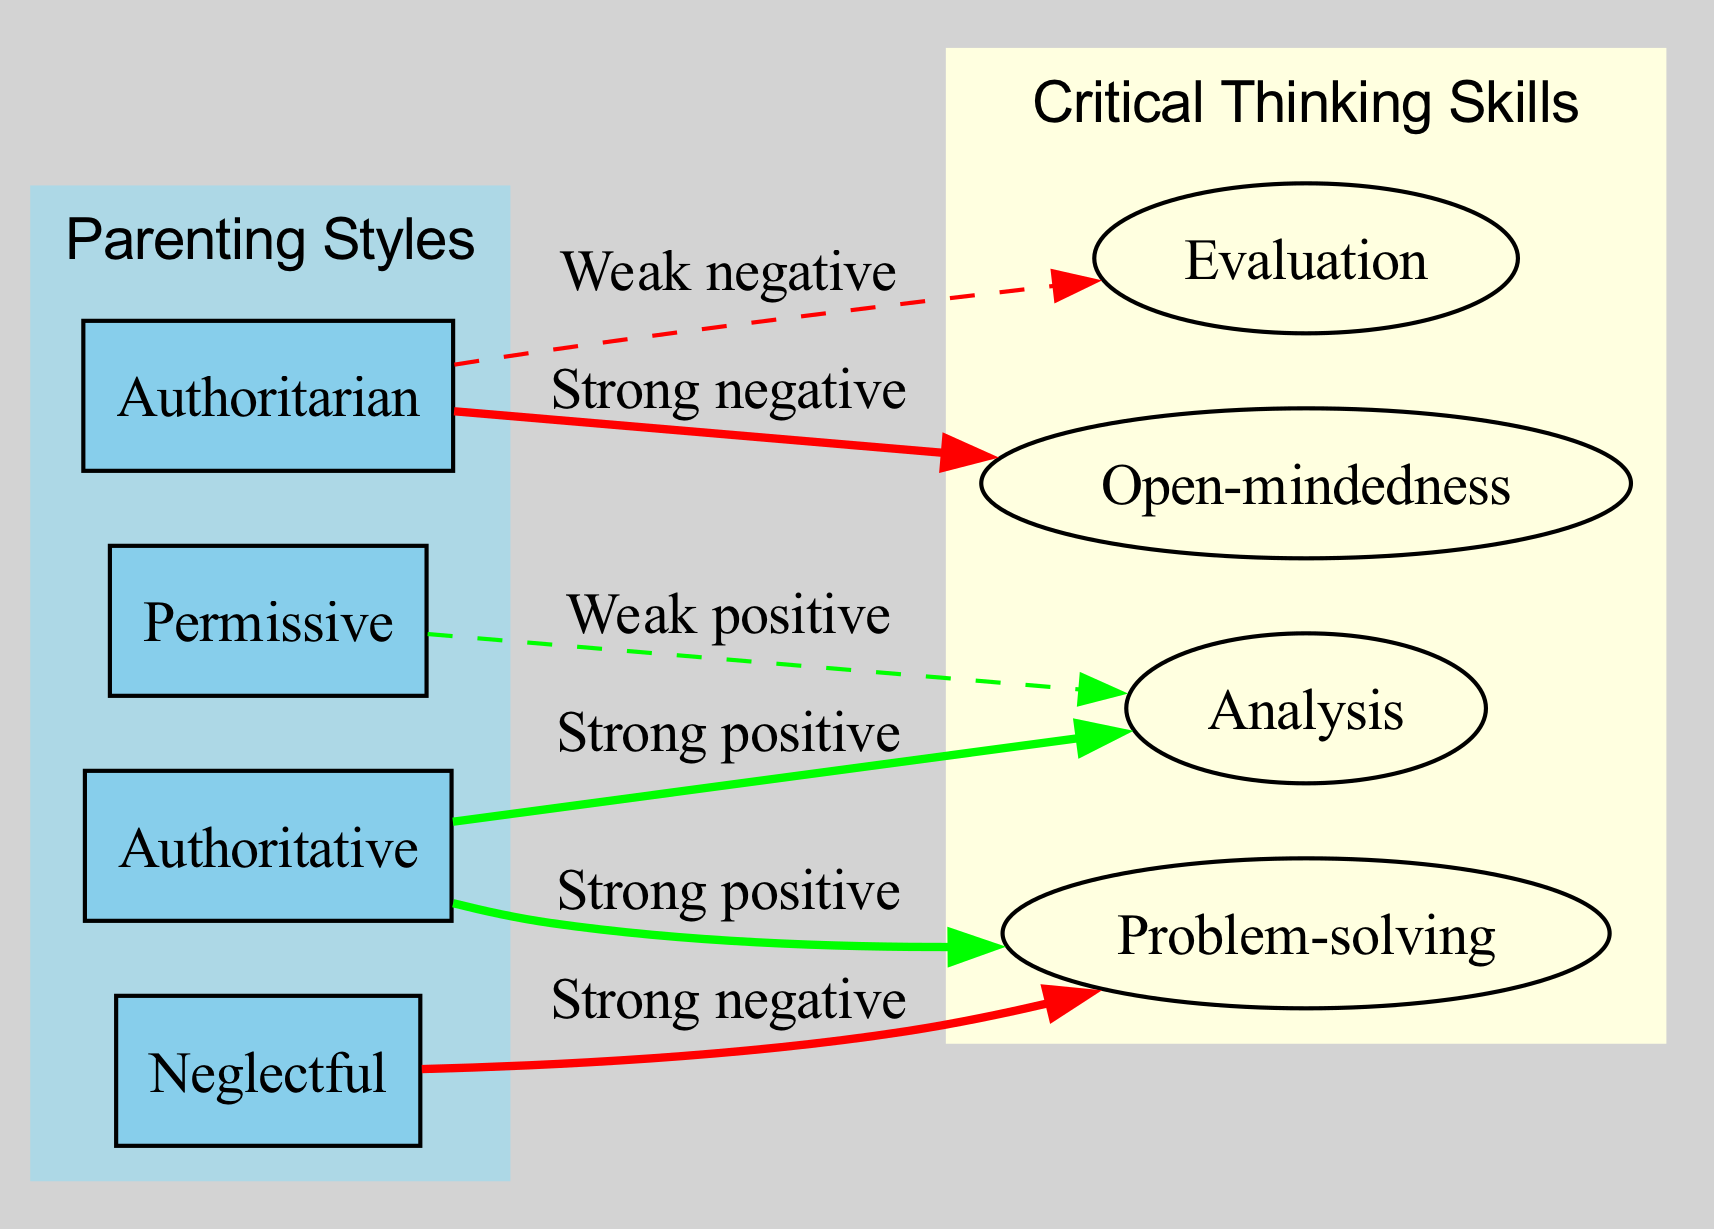What are the four types of parenting styles depicted in the diagram? The diagram lists four parenting styles: Authoritative, Authoritarian, Permissive, and Neglectful. These can be found under the "Parenting Styles" cluster.
Answer: Authoritative, Authoritarian, Permissive, Neglectful Which critical thinking skill has a strong positive correlation with Authoritative parenting? The diagram shows that both Analysis and Problem-solving have a strong positive correlation with Authoritative parenting, indicated by green edges.
Answer: Analysis, Problem-solving How many nodes are there in total? The diagram contains a total of ten nodes: four parenting styles, four critical thinking skills, and two clusters. Counting them gives us ten nodes altogether.
Answer: Ten What is the correlation between Authoritarian parenting and Open-mindedness? The diagram indicates a strong negative correlation between Authoritarian parenting and Open-mindedness, shown by a red edge from Authoritarian to Open-mindedness.
Answer: Strong negative Which parenting style is associated with Low Critical Thinking? The diagram's "Low Critical Thinking" cluster contains the Authoritarian and Neglectful parenting styles, indicating they are associated with lower critical thinking skills.
Answer: Authoritarian, Neglectful How many edges are there in total? By counting the edges in the diagram, we find that there are six total relationships depicted between parenting styles and critical thinking skills.
Answer: Six Which critical thinking skill is negatively correlated with Neglectful parenting? The edge from Neglectful to Problem-solving in the diagram indicates a strong negative correlation, highlighting that Neglectful parenting adversely affects Problem-solving skills.
Answer: Problem-solving Which style of parenting correlates with strong positive Analysis skills? According to the diagram, Authoritative parenting correlates with strong positive Analysis skills, supported by a green edge connecting them.
Answer: Authoritative In the diagram, what color represents the edges between negatively correlated nodes? The edges representing negative correlations are shown in red, signifying weaker or adverse relationships between those nodes.
Answer: Red 